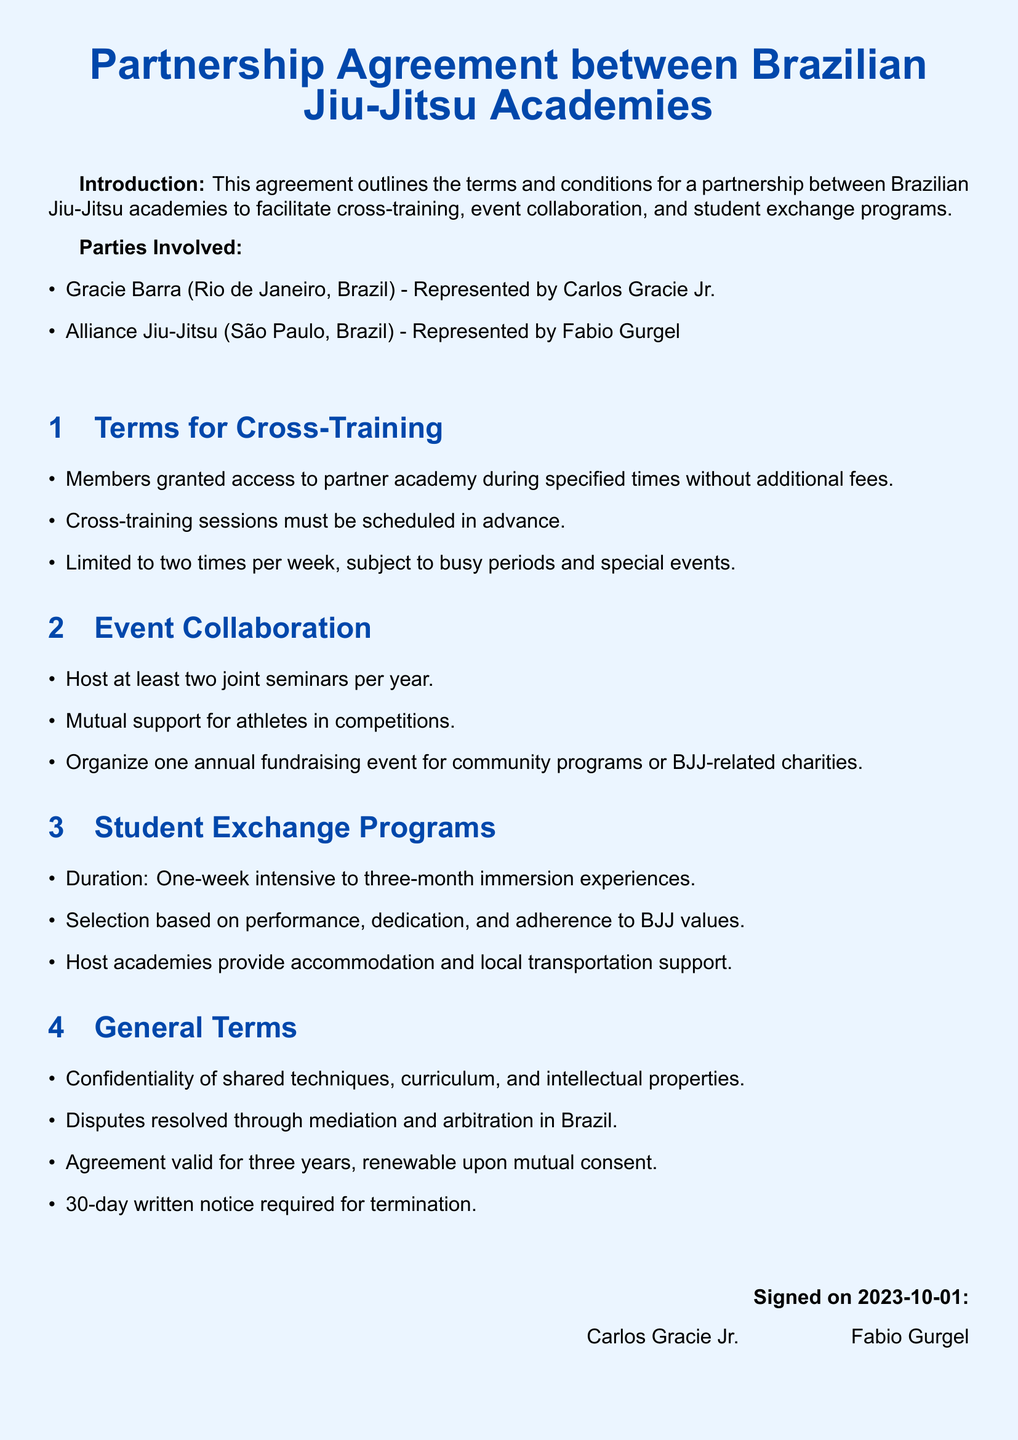What are the names of the academies involved? The document lists two academies involved in the partnership: Gracie Barra and Alliance Jiu-Jitsu.
Answer: Gracie Barra, Alliance Jiu-Jitsu Who represented Gracie Barra? The document specifies that Carlos Gracie Jr. is representing Gracie Barra in the agreement.
Answer: Carlos Gracie Jr How many joint seminars are to be hosted per year? The agreement states that the academies will host at least two joint seminars each year.
Answer: Two What is the maximum duration for student exchange programs? The document mentions that student exchange programs can last up to three months.
Answer: Three months What is required for the termination of the agreement? It states in the general terms section that a 30-day written notice is required for termination of the agreement.
Answer: 30-day written notice How often can members cross-train at the partner academy? The terms for cross-training specify that members can train up to two times per week.
Answer: Two times per week Where will disputes be resolved? The agreement specifies that disputes will be resolved through mediation and arbitration in Brazil.
Answer: Brazil What kind of support do host academies provide during student exchange programs? The document indicates that host academies provide accommodation and local transportation support for students.
Answer: Accommodation and local transportation support 